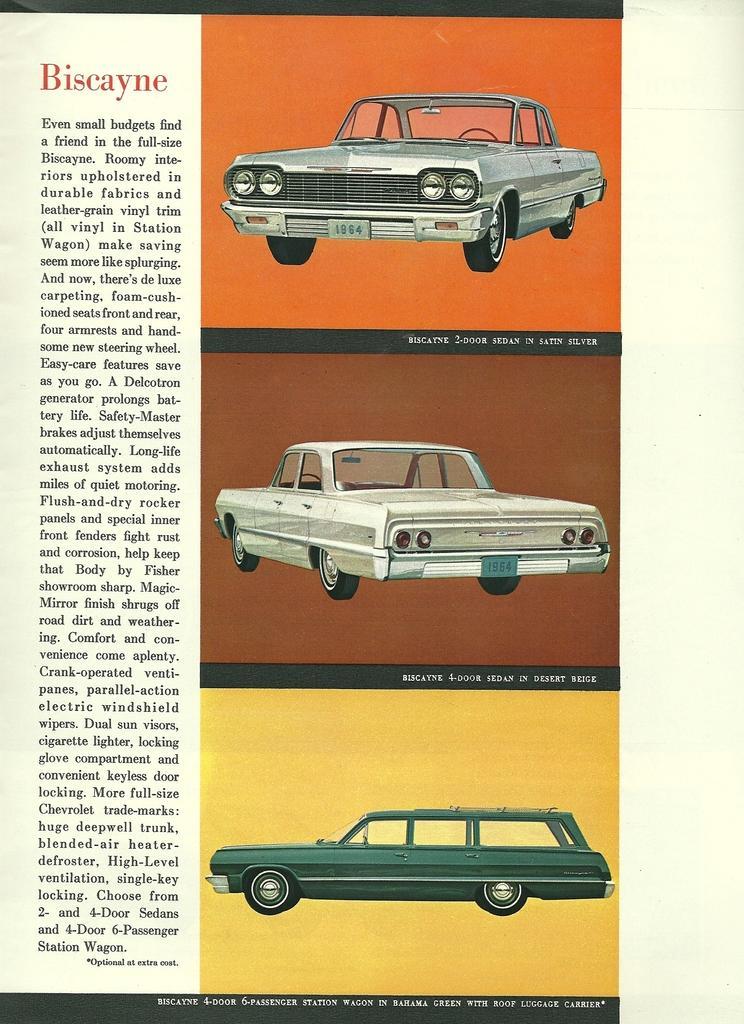How would you summarize this image in a sentence or two? In this image it seems like an article in which there are three cars one below the other on the right side. On the left side there is some script. 